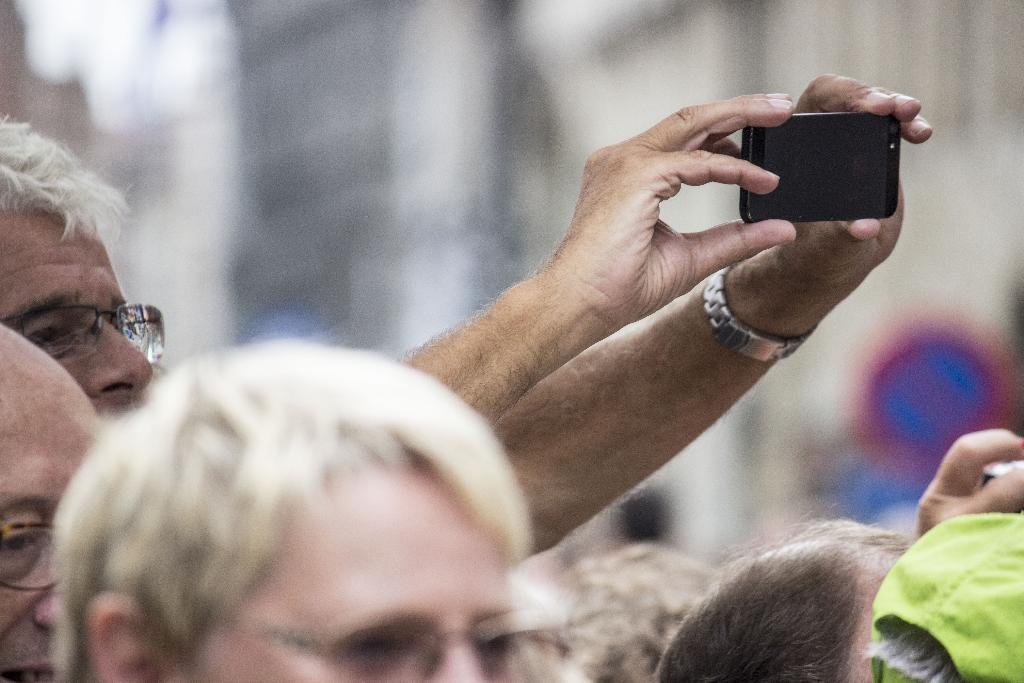Who is the main subject in the image? There is an old man in the image. What is the old man doing in the image? The old man is taking a picture with the phone he is holding in his hands. What accessory is the old man wearing in the image? The old man is wearing a watch. Are there any other people present in the image? Yes, there are people in the image. What type of curtain is hanging in the background of the image? There is no curtain present in the image. How does the tent in the image affect the old man's ability to take a picture? There is no tent present in the image. 